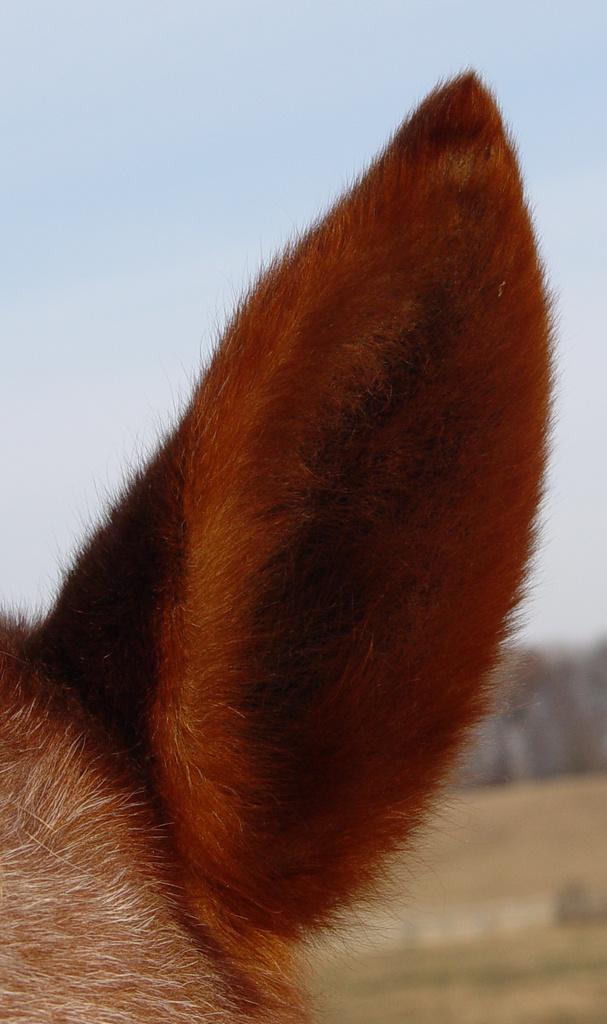In one or two sentences, can you explain what this image depicts? In this picture we can see an animal ear and in the background we can see the ground, sky and it is blurry. 